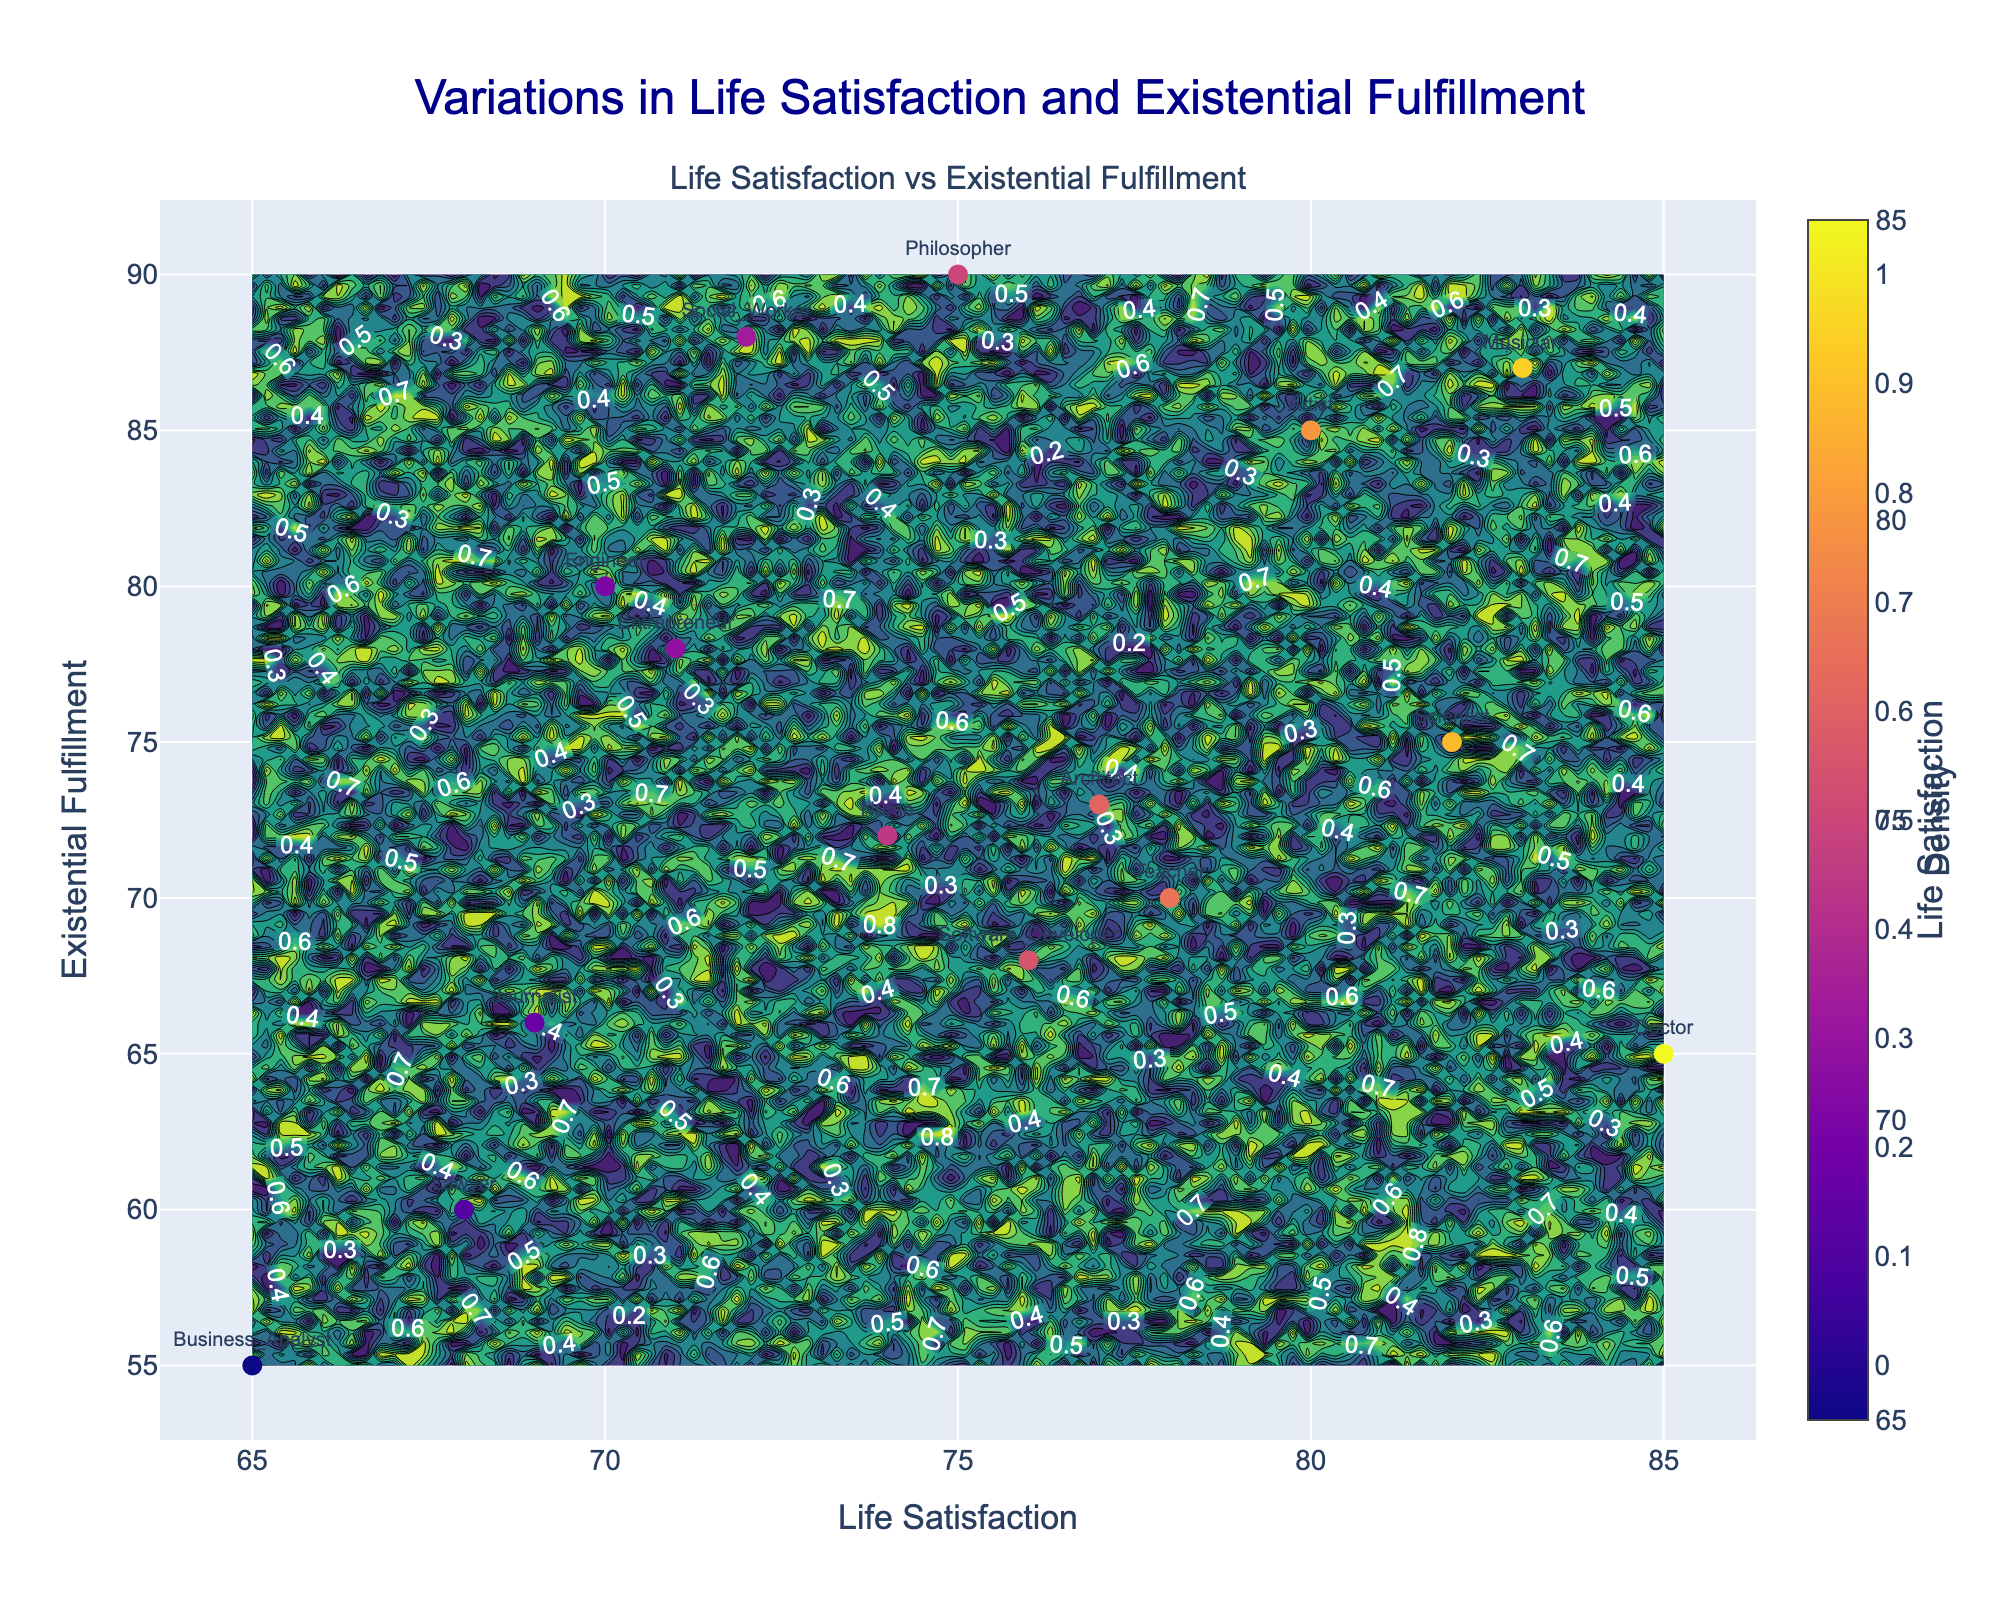What is the title of the figure? The title of the figure is displayed at the top in bold font, summarizing the content of the plot.
Answer: Variations in Life Satisfaction and Existential Fulfillment Which profession has the highest life satisfaction? Identify the point with the highest x-axis value, then look at the corresponding profession label.
Answer: Doctor How many data points are on the graph? Count the number of individual points represented on the scatter plot. Each point corresponds to a profession.
Answer: 15 What is the life satisfaction value for a Software Developer? Find the label "Software Developer" on the plot and read the x-axis value corresponding to this point.
Answer: 76 Which profession has higher existential fulfillment, Teacher or Architect? Locate both the "Teacher" and "Architect" points, then compare their y-axis values to determine which is higher.
Answer: Architect What is the average life satisfaction value of Engineer, Nurse, and Musician combined? Locate the points for Engineer, Nurse, and Musician and note their life satisfaction values (x-axis values). Sum these values and divide by the number of professions (3). (70 + 74 + 83) / 3 = 75.67
Answer: 75.67 Is there a profession with both lower life satisfaction and existential fulfillment than a Lawyer? Compare the Lawyer's x and y values with other professions. If both values for any profession are less than those of the Lawyer, the answer will be yes. Since no other profession has both values lower, the answer is no.
Answer: No Which profession has the greatest difference between life satisfaction and existential fulfillment? For each profession, calculate the absolute difference between their x (life satisfaction) and y (existential fulfillment) values. Identify the profession with the largest difference.
Answer: Doctor Which density region, high or low, appears more towards higher life satisfaction and existential fulfillment? Examine the contour plot color gradient. Regions of higher density (brighter colors) or lower density (darker colors) are located. Identify which density is more prominent in the upper right of the plot.
Answer: Low density What professions fall into the highest contour density region? Observe the regions with the highest density (brightest areas) and note the professions within or near these regions.
Answer: None 